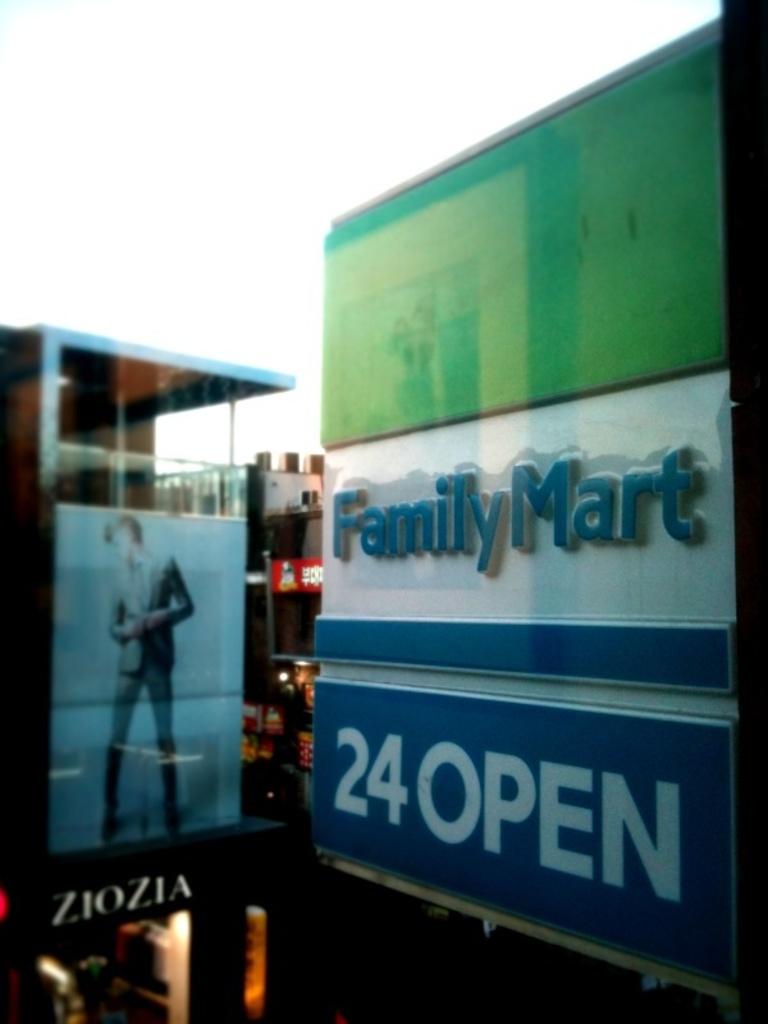When does this store close?
Keep it short and to the point. Never. What is the name of the store?
Keep it short and to the point. Family mart. 